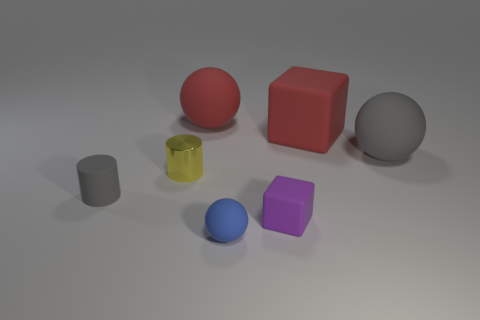Is there any other thing that has the same material as the yellow object? Based on the image, it appears that all the objects presented may be made of the same material, typically in a 3D rendering, these objects could be considered to have similar properties such as being diffuse and having a matte finish. However, without additional context or information about the specific properties of the materials, we cannot definitively say they are the same. The objects all demonstrate unique colors and potentially could differ in material attributes like reflectiveness, texture, and hardness. 